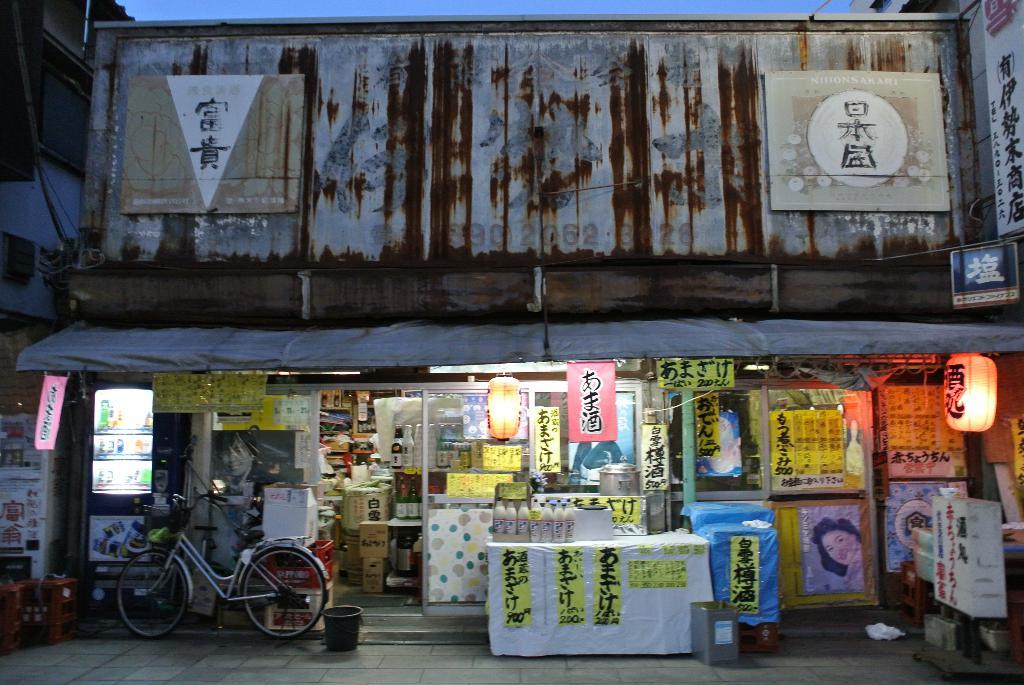How many bicycles are there?
Give a very brief answer. Answering does not require reading text in the image. 